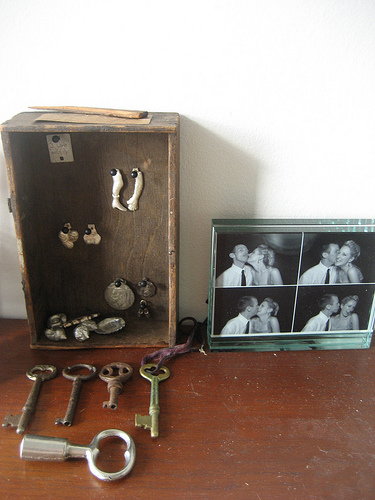<image>
Is there a arm figure in the box? Yes. The arm figure is contained within or inside the box, showing a containment relationship. 